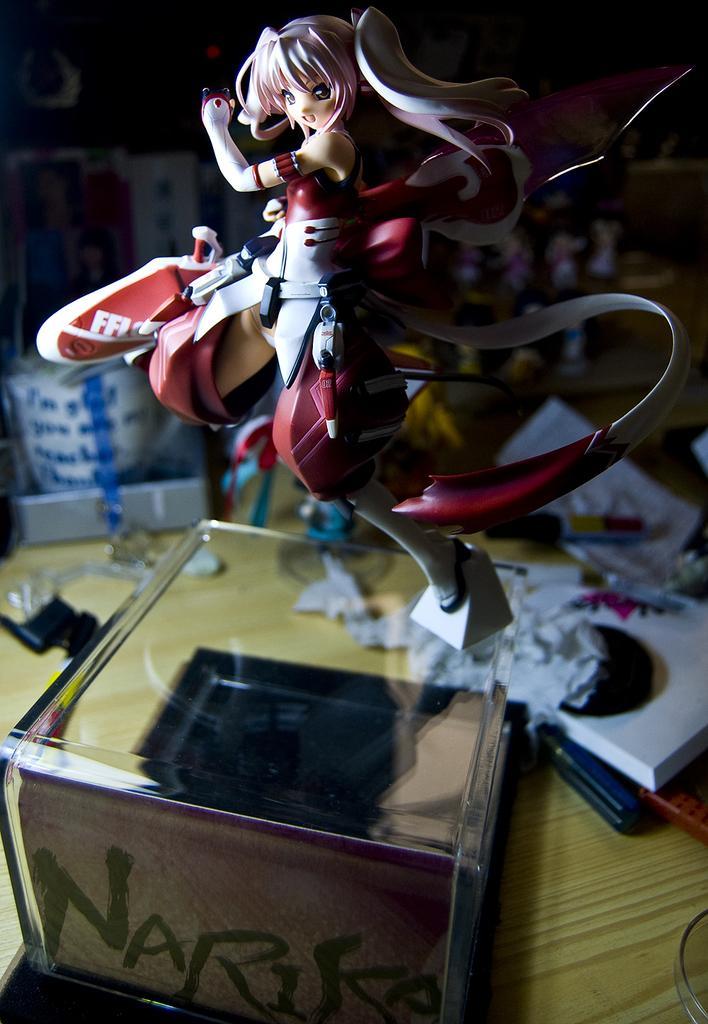Could you give a brief overview of what you see in this image? In the center of this picture we can see a showpiece of a woman wearing red color dress and we can see there are some objects placed on the top of the wooden table. In the background we can see some other objects. 